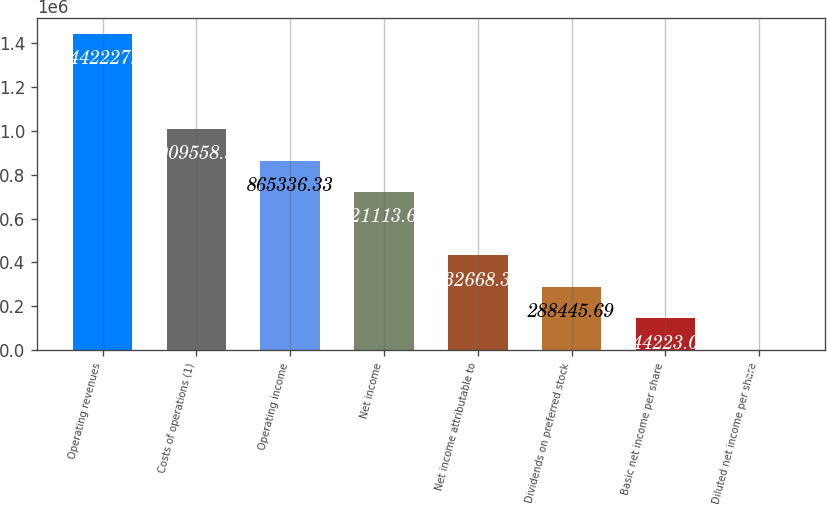Convert chart. <chart><loc_0><loc_0><loc_500><loc_500><bar_chart><fcel>Operating revenues<fcel>Costs of operations (1)<fcel>Operating income<fcel>Net income<fcel>Net income attributable to<fcel>Dividends on preferred stock<fcel>Basic net income per share<fcel>Diluted net income per share<nl><fcel>1.44223e+06<fcel>1.00956e+06<fcel>865336<fcel>721114<fcel>432668<fcel>288446<fcel>144223<fcel>0.37<nl></chart> 